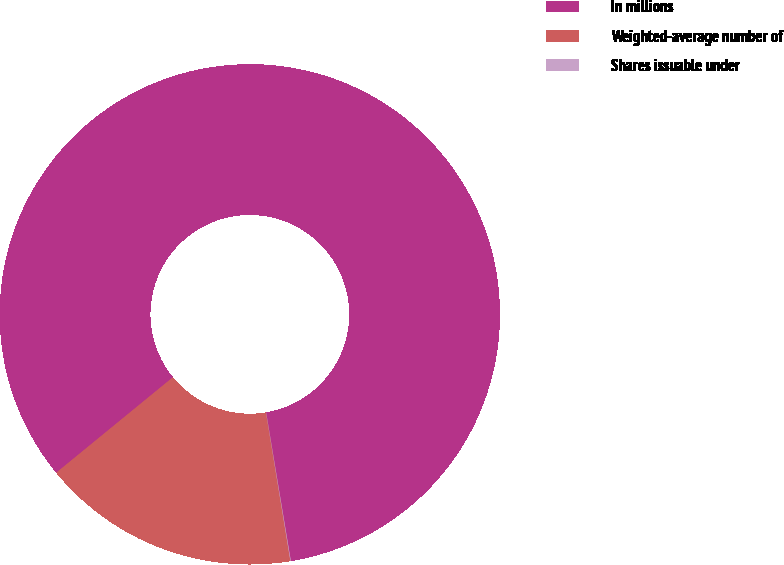Convert chart to OTSL. <chart><loc_0><loc_0><loc_500><loc_500><pie_chart><fcel>In millions<fcel>Weighted-average number of<fcel>Shares issuable under<nl><fcel>83.29%<fcel>16.68%<fcel>0.03%<nl></chart> 